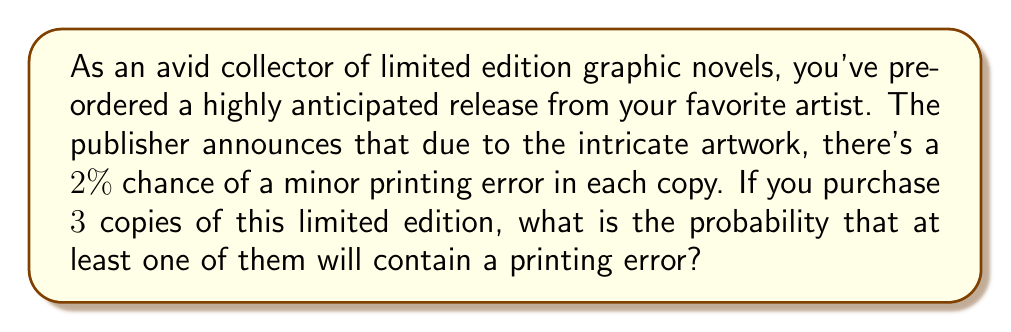Could you help me with this problem? Let's approach this step-by-step:

1) First, let's define our events:
   Let E be the event of encountering a printing error in a single copy.

2) We're given that P(E) = 0.02 (2% chance of error)

3) It's easier to calculate the probability of at least one error by first finding the probability of no errors and then subtracting from 1.

4) For no errors in 3 copies, we need all 3 copies to be error-free.
   Probability of no error in a single copy = 1 - P(E) = 1 - 0.02 = 0.98

5) Assuming independence between copies, the probability of no errors in all 3 copies is:
   $$(0.98)^3 = 0.941192$$

6) Therefore, the probability of at least one error in 3 copies is:
   $$1 - (0.98)^3 = 1 - 0.941192 = 0.058808$$

7) Converting to a percentage:
   $$0.058808 \times 100\% = 5.8808\%$$

Thus, there's approximately a 5.88% chance that at least one of the three copies will contain a printing error.
Answer: The probability of encountering at least one printing error in 3 copies of the limited edition graphic novel is approximately 5.88% or 0.0588. 